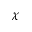<formula> <loc_0><loc_0><loc_500><loc_500>\chi</formula> 